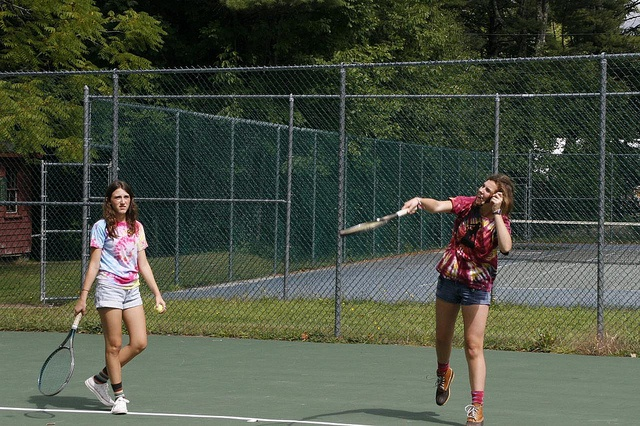Describe the objects in this image and their specific colors. I can see people in black, maroon, gray, and tan tones, people in black, lavender, gray, and tan tones, tennis racket in black, gray, and darkgray tones, tennis racket in black, gray, darkgray, and white tones, and sports ball in black, khaki, olive, tan, and lightyellow tones in this image. 